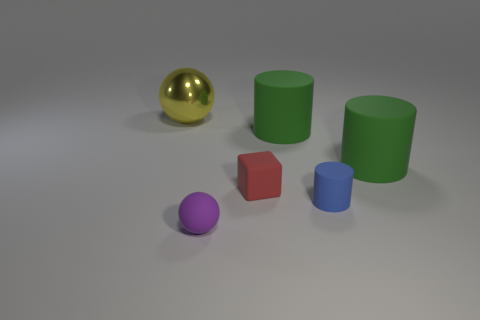There is a big green cylinder that is left of the small object that is on the right side of the small red block; what is its material?
Offer a very short reply. Rubber. Is there anything else that is the same size as the red matte block?
Give a very brief answer. Yes. Is the size of the shiny ball the same as the purple matte object?
Provide a succinct answer. No. How many things are either small things that are right of the big yellow metal thing or objects that are behind the small purple rubber ball?
Your response must be concise. 6. Is the number of tiny blue cylinders to the left of the tiny red object greater than the number of matte cylinders?
Provide a succinct answer. No. How many other things are there of the same shape as the purple object?
Your answer should be compact. 1. What is the object that is in front of the small red object and on the right side of the tiny purple thing made of?
Provide a succinct answer. Rubber. How many objects are large blue objects or blue matte objects?
Give a very brief answer. 1. Are there more large balls than tiny gray shiny objects?
Provide a short and direct response. Yes. There is a sphere that is behind the tiny matte thing left of the small red matte cube; what size is it?
Your answer should be compact. Large. 